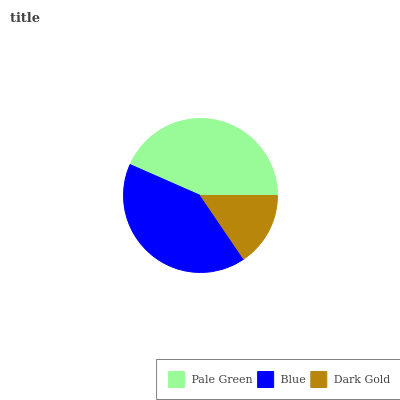Is Dark Gold the minimum?
Answer yes or no. Yes. Is Pale Green the maximum?
Answer yes or no. Yes. Is Blue the minimum?
Answer yes or no. No. Is Blue the maximum?
Answer yes or no. No. Is Pale Green greater than Blue?
Answer yes or no. Yes. Is Blue less than Pale Green?
Answer yes or no. Yes. Is Blue greater than Pale Green?
Answer yes or no. No. Is Pale Green less than Blue?
Answer yes or no. No. Is Blue the high median?
Answer yes or no. Yes. Is Blue the low median?
Answer yes or no. Yes. Is Pale Green the high median?
Answer yes or no. No. Is Dark Gold the low median?
Answer yes or no. No. 